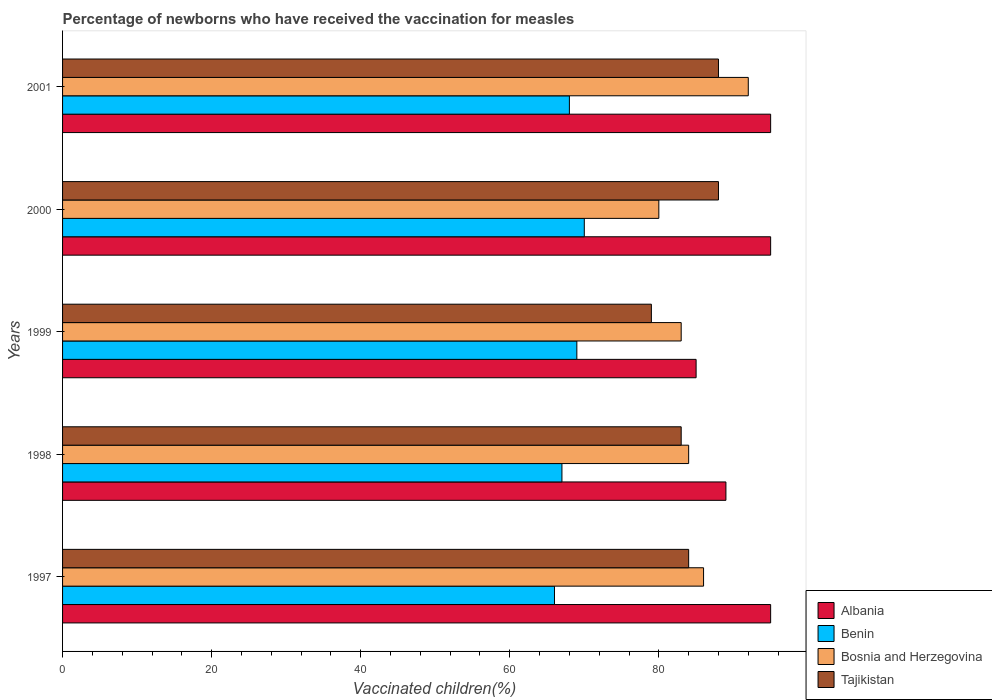How many different coloured bars are there?
Ensure brevity in your answer.  4. Are the number of bars per tick equal to the number of legend labels?
Keep it short and to the point. Yes. What is the label of the 2nd group of bars from the top?
Provide a short and direct response. 2000. What is the percentage of vaccinated children in Albania in 2001?
Your response must be concise. 95. Across all years, what is the maximum percentage of vaccinated children in Benin?
Offer a very short reply. 70. What is the total percentage of vaccinated children in Bosnia and Herzegovina in the graph?
Your answer should be compact. 425. What is the difference between the percentage of vaccinated children in Bosnia and Herzegovina in 1997 and that in 1999?
Offer a terse response. 3. What is the difference between the percentage of vaccinated children in Benin in 1998 and the percentage of vaccinated children in Albania in 1999?
Provide a short and direct response. -18. What is the average percentage of vaccinated children in Tajikistan per year?
Offer a very short reply. 84.4. In the year 2000, what is the difference between the percentage of vaccinated children in Albania and percentage of vaccinated children in Tajikistan?
Ensure brevity in your answer.  7. What is the ratio of the percentage of vaccinated children in Benin in 1997 to that in 1999?
Provide a succinct answer. 0.96. Is the percentage of vaccinated children in Benin in 1999 less than that in 2001?
Make the answer very short. No. What is the difference between the highest and the second highest percentage of vaccinated children in Tajikistan?
Your response must be concise. 0. In how many years, is the percentage of vaccinated children in Albania greater than the average percentage of vaccinated children in Albania taken over all years?
Your response must be concise. 3. What does the 3rd bar from the top in 2001 represents?
Your response must be concise. Benin. What does the 4th bar from the bottom in 2000 represents?
Offer a very short reply. Tajikistan. Is it the case that in every year, the sum of the percentage of vaccinated children in Tajikistan and percentage of vaccinated children in Benin is greater than the percentage of vaccinated children in Albania?
Offer a very short reply. Yes. How many bars are there?
Offer a terse response. 20. Are all the bars in the graph horizontal?
Offer a very short reply. Yes. What is the difference between two consecutive major ticks on the X-axis?
Offer a very short reply. 20. Are the values on the major ticks of X-axis written in scientific E-notation?
Your answer should be very brief. No. Does the graph contain any zero values?
Keep it short and to the point. No. Does the graph contain grids?
Offer a very short reply. No. Where does the legend appear in the graph?
Your answer should be compact. Bottom right. How many legend labels are there?
Ensure brevity in your answer.  4. What is the title of the graph?
Your answer should be compact. Percentage of newborns who have received the vaccination for measles. What is the label or title of the X-axis?
Your response must be concise. Vaccinated children(%). What is the label or title of the Y-axis?
Provide a succinct answer. Years. What is the Vaccinated children(%) of Benin in 1997?
Your response must be concise. 66. What is the Vaccinated children(%) of Bosnia and Herzegovina in 1997?
Your answer should be very brief. 86. What is the Vaccinated children(%) in Albania in 1998?
Ensure brevity in your answer.  89. What is the Vaccinated children(%) of Bosnia and Herzegovina in 1998?
Make the answer very short. 84. What is the Vaccinated children(%) in Benin in 1999?
Ensure brevity in your answer.  69. What is the Vaccinated children(%) of Tajikistan in 1999?
Make the answer very short. 79. What is the Vaccinated children(%) of Benin in 2000?
Make the answer very short. 70. What is the Vaccinated children(%) in Bosnia and Herzegovina in 2000?
Your answer should be compact. 80. What is the Vaccinated children(%) of Tajikistan in 2000?
Give a very brief answer. 88. What is the Vaccinated children(%) of Albania in 2001?
Provide a succinct answer. 95. What is the Vaccinated children(%) of Benin in 2001?
Ensure brevity in your answer.  68. What is the Vaccinated children(%) in Bosnia and Herzegovina in 2001?
Offer a terse response. 92. Across all years, what is the maximum Vaccinated children(%) in Benin?
Offer a terse response. 70. Across all years, what is the maximum Vaccinated children(%) in Bosnia and Herzegovina?
Give a very brief answer. 92. Across all years, what is the minimum Vaccinated children(%) in Albania?
Your answer should be very brief. 85. Across all years, what is the minimum Vaccinated children(%) of Tajikistan?
Make the answer very short. 79. What is the total Vaccinated children(%) in Albania in the graph?
Your response must be concise. 459. What is the total Vaccinated children(%) of Benin in the graph?
Ensure brevity in your answer.  340. What is the total Vaccinated children(%) in Bosnia and Herzegovina in the graph?
Ensure brevity in your answer.  425. What is the total Vaccinated children(%) in Tajikistan in the graph?
Make the answer very short. 422. What is the difference between the Vaccinated children(%) in Albania in 1997 and that in 1998?
Provide a succinct answer. 6. What is the difference between the Vaccinated children(%) of Benin in 1997 and that in 1998?
Your answer should be very brief. -1. What is the difference between the Vaccinated children(%) of Bosnia and Herzegovina in 1997 and that in 1998?
Your response must be concise. 2. What is the difference between the Vaccinated children(%) of Albania in 1997 and that in 1999?
Give a very brief answer. 10. What is the difference between the Vaccinated children(%) in Benin in 1997 and that in 1999?
Provide a short and direct response. -3. What is the difference between the Vaccinated children(%) of Bosnia and Herzegovina in 1997 and that in 2000?
Your response must be concise. 6. What is the difference between the Vaccinated children(%) of Tajikistan in 1997 and that in 2000?
Ensure brevity in your answer.  -4. What is the difference between the Vaccinated children(%) of Bosnia and Herzegovina in 1998 and that in 1999?
Ensure brevity in your answer.  1. What is the difference between the Vaccinated children(%) of Benin in 1998 and that in 2000?
Provide a succinct answer. -3. What is the difference between the Vaccinated children(%) in Tajikistan in 1998 and that in 2000?
Provide a short and direct response. -5. What is the difference between the Vaccinated children(%) in Albania in 1998 and that in 2001?
Make the answer very short. -6. What is the difference between the Vaccinated children(%) of Benin in 1998 and that in 2001?
Your answer should be compact. -1. What is the difference between the Vaccinated children(%) of Bosnia and Herzegovina in 1998 and that in 2001?
Make the answer very short. -8. What is the difference between the Vaccinated children(%) of Tajikistan in 1998 and that in 2001?
Give a very brief answer. -5. What is the difference between the Vaccinated children(%) in Bosnia and Herzegovina in 1999 and that in 2000?
Your response must be concise. 3. What is the difference between the Vaccinated children(%) of Tajikistan in 1999 and that in 2000?
Offer a very short reply. -9. What is the difference between the Vaccinated children(%) of Benin in 1999 and that in 2001?
Provide a succinct answer. 1. What is the difference between the Vaccinated children(%) of Bosnia and Herzegovina in 2000 and that in 2001?
Provide a succinct answer. -12. What is the difference between the Vaccinated children(%) of Tajikistan in 2000 and that in 2001?
Provide a short and direct response. 0. What is the difference between the Vaccinated children(%) of Albania in 1997 and the Vaccinated children(%) of Benin in 1998?
Keep it short and to the point. 28. What is the difference between the Vaccinated children(%) in Albania in 1997 and the Vaccinated children(%) in Bosnia and Herzegovina in 1998?
Provide a short and direct response. 11. What is the difference between the Vaccinated children(%) in Albania in 1997 and the Vaccinated children(%) in Tajikistan in 1998?
Give a very brief answer. 12. What is the difference between the Vaccinated children(%) in Benin in 1997 and the Vaccinated children(%) in Tajikistan in 1998?
Your answer should be compact. -17. What is the difference between the Vaccinated children(%) in Albania in 1997 and the Vaccinated children(%) in Benin in 1999?
Provide a succinct answer. 26. What is the difference between the Vaccinated children(%) of Albania in 1997 and the Vaccinated children(%) of Bosnia and Herzegovina in 1999?
Offer a terse response. 12. What is the difference between the Vaccinated children(%) of Albania in 1997 and the Vaccinated children(%) of Tajikistan in 1999?
Your response must be concise. 16. What is the difference between the Vaccinated children(%) in Benin in 1997 and the Vaccinated children(%) in Tajikistan in 1999?
Your response must be concise. -13. What is the difference between the Vaccinated children(%) of Bosnia and Herzegovina in 1997 and the Vaccinated children(%) of Tajikistan in 1999?
Give a very brief answer. 7. What is the difference between the Vaccinated children(%) of Albania in 1997 and the Vaccinated children(%) of Benin in 2000?
Keep it short and to the point. 25. What is the difference between the Vaccinated children(%) of Benin in 1997 and the Vaccinated children(%) of Bosnia and Herzegovina in 2000?
Provide a short and direct response. -14. What is the difference between the Vaccinated children(%) in Benin in 1997 and the Vaccinated children(%) in Tajikistan in 2000?
Ensure brevity in your answer.  -22. What is the difference between the Vaccinated children(%) of Bosnia and Herzegovina in 1997 and the Vaccinated children(%) of Tajikistan in 2000?
Your response must be concise. -2. What is the difference between the Vaccinated children(%) of Albania in 1997 and the Vaccinated children(%) of Benin in 2001?
Provide a succinct answer. 27. What is the difference between the Vaccinated children(%) of Albania in 1997 and the Vaccinated children(%) of Bosnia and Herzegovina in 2001?
Offer a very short reply. 3. What is the difference between the Vaccinated children(%) of Benin in 1997 and the Vaccinated children(%) of Tajikistan in 2001?
Your answer should be very brief. -22. What is the difference between the Vaccinated children(%) in Bosnia and Herzegovina in 1997 and the Vaccinated children(%) in Tajikistan in 2001?
Give a very brief answer. -2. What is the difference between the Vaccinated children(%) in Albania in 1998 and the Vaccinated children(%) in Benin in 1999?
Provide a succinct answer. 20. What is the difference between the Vaccinated children(%) in Albania in 1998 and the Vaccinated children(%) in Tajikistan in 1999?
Give a very brief answer. 10. What is the difference between the Vaccinated children(%) of Bosnia and Herzegovina in 1998 and the Vaccinated children(%) of Tajikistan in 1999?
Give a very brief answer. 5. What is the difference between the Vaccinated children(%) of Albania in 1998 and the Vaccinated children(%) of Benin in 2000?
Keep it short and to the point. 19. What is the difference between the Vaccinated children(%) of Albania in 1998 and the Vaccinated children(%) of Bosnia and Herzegovina in 2000?
Your answer should be very brief. 9. What is the difference between the Vaccinated children(%) of Albania in 1998 and the Vaccinated children(%) of Tajikistan in 2000?
Offer a very short reply. 1. What is the difference between the Vaccinated children(%) in Benin in 1998 and the Vaccinated children(%) in Bosnia and Herzegovina in 2000?
Keep it short and to the point. -13. What is the difference between the Vaccinated children(%) of Benin in 1998 and the Vaccinated children(%) of Tajikistan in 2000?
Your answer should be compact. -21. What is the difference between the Vaccinated children(%) of Albania in 1998 and the Vaccinated children(%) of Benin in 2001?
Your answer should be very brief. 21. What is the difference between the Vaccinated children(%) of Benin in 1998 and the Vaccinated children(%) of Bosnia and Herzegovina in 2001?
Provide a succinct answer. -25. What is the difference between the Vaccinated children(%) of Benin in 1998 and the Vaccinated children(%) of Tajikistan in 2001?
Your answer should be compact. -21. What is the difference between the Vaccinated children(%) in Albania in 1999 and the Vaccinated children(%) in Bosnia and Herzegovina in 2000?
Provide a succinct answer. 5. What is the difference between the Vaccinated children(%) in Benin in 1999 and the Vaccinated children(%) in Bosnia and Herzegovina in 2000?
Your answer should be very brief. -11. What is the difference between the Vaccinated children(%) of Benin in 1999 and the Vaccinated children(%) of Tajikistan in 2000?
Your answer should be compact. -19. What is the difference between the Vaccinated children(%) of Albania in 1999 and the Vaccinated children(%) of Benin in 2001?
Your answer should be compact. 17. What is the difference between the Vaccinated children(%) of Benin in 1999 and the Vaccinated children(%) of Bosnia and Herzegovina in 2001?
Your answer should be compact. -23. What is the difference between the Vaccinated children(%) in Bosnia and Herzegovina in 1999 and the Vaccinated children(%) in Tajikistan in 2001?
Your response must be concise. -5. What is the difference between the Vaccinated children(%) in Albania in 2000 and the Vaccinated children(%) in Benin in 2001?
Keep it short and to the point. 27. What is the difference between the Vaccinated children(%) in Albania in 2000 and the Vaccinated children(%) in Tajikistan in 2001?
Your response must be concise. 7. What is the difference between the Vaccinated children(%) of Benin in 2000 and the Vaccinated children(%) of Bosnia and Herzegovina in 2001?
Your answer should be very brief. -22. What is the average Vaccinated children(%) in Albania per year?
Your answer should be very brief. 91.8. What is the average Vaccinated children(%) of Benin per year?
Give a very brief answer. 68. What is the average Vaccinated children(%) of Tajikistan per year?
Ensure brevity in your answer.  84.4. In the year 1997, what is the difference between the Vaccinated children(%) in Albania and Vaccinated children(%) in Benin?
Offer a very short reply. 29. In the year 1997, what is the difference between the Vaccinated children(%) of Albania and Vaccinated children(%) of Bosnia and Herzegovina?
Offer a very short reply. 9. In the year 1997, what is the difference between the Vaccinated children(%) of Albania and Vaccinated children(%) of Tajikistan?
Make the answer very short. 11. In the year 1998, what is the difference between the Vaccinated children(%) in Benin and Vaccinated children(%) in Tajikistan?
Ensure brevity in your answer.  -16. In the year 1999, what is the difference between the Vaccinated children(%) of Albania and Vaccinated children(%) of Bosnia and Herzegovina?
Make the answer very short. 2. In the year 1999, what is the difference between the Vaccinated children(%) in Albania and Vaccinated children(%) in Tajikistan?
Make the answer very short. 6. In the year 1999, what is the difference between the Vaccinated children(%) in Benin and Vaccinated children(%) in Bosnia and Herzegovina?
Make the answer very short. -14. In the year 1999, what is the difference between the Vaccinated children(%) in Benin and Vaccinated children(%) in Tajikistan?
Your answer should be compact. -10. In the year 2000, what is the difference between the Vaccinated children(%) in Benin and Vaccinated children(%) in Bosnia and Herzegovina?
Your answer should be very brief. -10. In the year 2001, what is the difference between the Vaccinated children(%) of Albania and Vaccinated children(%) of Benin?
Offer a very short reply. 27. In the year 2001, what is the difference between the Vaccinated children(%) in Bosnia and Herzegovina and Vaccinated children(%) in Tajikistan?
Your response must be concise. 4. What is the ratio of the Vaccinated children(%) of Albania in 1997 to that in 1998?
Make the answer very short. 1.07. What is the ratio of the Vaccinated children(%) of Benin in 1997 to that in 1998?
Make the answer very short. 0.99. What is the ratio of the Vaccinated children(%) in Bosnia and Herzegovina in 1997 to that in 1998?
Your answer should be compact. 1.02. What is the ratio of the Vaccinated children(%) in Tajikistan in 1997 to that in 1998?
Provide a short and direct response. 1.01. What is the ratio of the Vaccinated children(%) of Albania in 1997 to that in 1999?
Your response must be concise. 1.12. What is the ratio of the Vaccinated children(%) of Benin in 1997 to that in 1999?
Offer a terse response. 0.96. What is the ratio of the Vaccinated children(%) in Bosnia and Herzegovina in 1997 to that in 1999?
Make the answer very short. 1.04. What is the ratio of the Vaccinated children(%) in Tajikistan in 1997 to that in 1999?
Make the answer very short. 1.06. What is the ratio of the Vaccinated children(%) of Albania in 1997 to that in 2000?
Your answer should be compact. 1. What is the ratio of the Vaccinated children(%) of Benin in 1997 to that in 2000?
Keep it short and to the point. 0.94. What is the ratio of the Vaccinated children(%) of Bosnia and Herzegovina in 1997 to that in 2000?
Ensure brevity in your answer.  1.07. What is the ratio of the Vaccinated children(%) of Tajikistan in 1997 to that in 2000?
Offer a terse response. 0.95. What is the ratio of the Vaccinated children(%) in Benin in 1997 to that in 2001?
Offer a terse response. 0.97. What is the ratio of the Vaccinated children(%) in Bosnia and Herzegovina in 1997 to that in 2001?
Offer a very short reply. 0.93. What is the ratio of the Vaccinated children(%) in Tajikistan in 1997 to that in 2001?
Your answer should be compact. 0.95. What is the ratio of the Vaccinated children(%) in Albania in 1998 to that in 1999?
Offer a very short reply. 1.05. What is the ratio of the Vaccinated children(%) of Tajikistan in 1998 to that in 1999?
Your response must be concise. 1.05. What is the ratio of the Vaccinated children(%) of Albania in 1998 to that in 2000?
Provide a short and direct response. 0.94. What is the ratio of the Vaccinated children(%) in Benin in 1998 to that in 2000?
Offer a terse response. 0.96. What is the ratio of the Vaccinated children(%) in Tajikistan in 1998 to that in 2000?
Offer a terse response. 0.94. What is the ratio of the Vaccinated children(%) of Albania in 1998 to that in 2001?
Make the answer very short. 0.94. What is the ratio of the Vaccinated children(%) of Benin in 1998 to that in 2001?
Your answer should be compact. 0.99. What is the ratio of the Vaccinated children(%) in Tajikistan in 1998 to that in 2001?
Your response must be concise. 0.94. What is the ratio of the Vaccinated children(%) in Albania in 1999 to that in 2000?
Give a very brief answer. 0.89. What is the ratio of the Vaccinated children(%) in Benin in 1999 to that in 2000?
Give a very brief answer. 0.99. What is the ratio of the Vaccinated children(%) in Bosnia and Herzegovina in 1999 to that in 2000?
Make the answer very short. 1.04. What is the ratio of the Vaccinated children(%) of Tajikistan in 1999 to that in 2000?
Offer a very short reply. 0.9. What is the ratio of the Vaccinated children(%) of Albania in 1999 to that in 2001?
Offer a terse response. 0.89. What is the ratio of the Vaccinated children(%) in Benin in 1999 to that in 2001?
Ensure brevity in your answer.  1.01. What is the ratio of the Vaccinated children(%) in Bosnia and Herzegovina in 1999 to that in 2001?
Give a very brief answer. 0.9. What is the ratio of the Vaccinated children(%) of Tajikistan in 1999 to that in 2001?
Make the answer very short. 0.9. What is the ratio of the Vaccinated children(%) in Benin in 2000 to that in 2001?
Provide a succinct answer. 1.03. What is the ratio of the Vaccinated children(%) in Bosnia and Herzegovina in 2000 to that in 2001?
Your response must be concise. 0.87. What is the ratio of the Vaccinated children(%) of Tajikistan in 2000 to that in 2001?
Give a very brief answer. 1. What is the difference between the highest and the second highest Vaccinated children(%) of Tajikistan?
Provide a short and direct response. 0. What is the difference between the highest and the lowest Vaccinated children(%) of Albania?
Make the answer very short. 10. What is the difference between the highest and the lowest Vaccinated children(%) of Benin?
Provide a short and direct response. 4. What is the difference between the highest and the lowest Vaccinated children(%) in Bosnia and Herzegovina?
Keep it short and to the point. 12. What is the difference between the highest and the lowest Vaccinated children(%) in Tajikistan?
Provide a succinct answer. 9. 